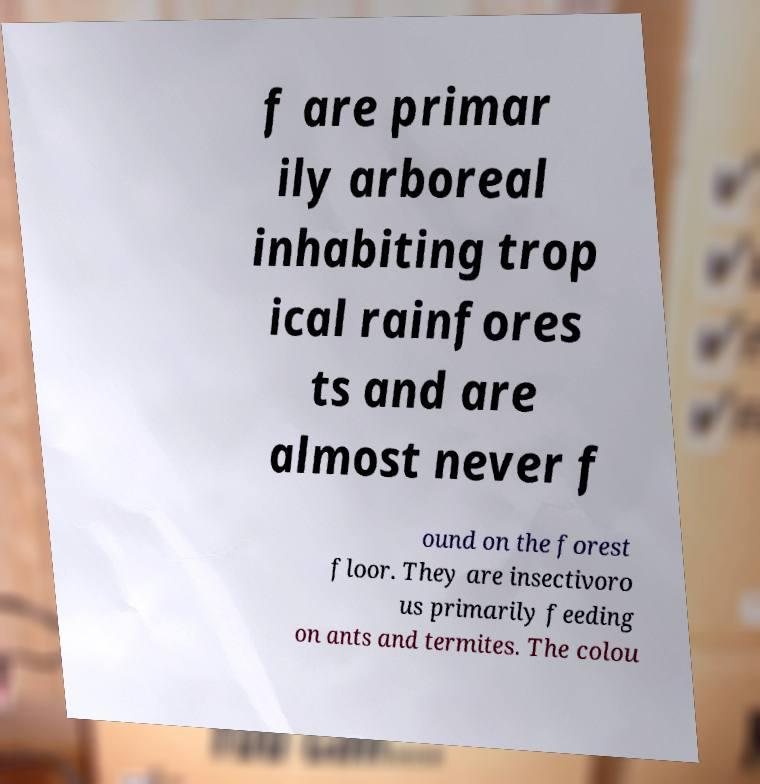There's text embedded in this image that I need extracted. Can you transcribe it verbatim? f are primar ily arboreal inhabiting trop ical rainfores ts and are almost never f ound on the forest floor. They are insectivoro us primarily feeding on ants and termites. The colou 